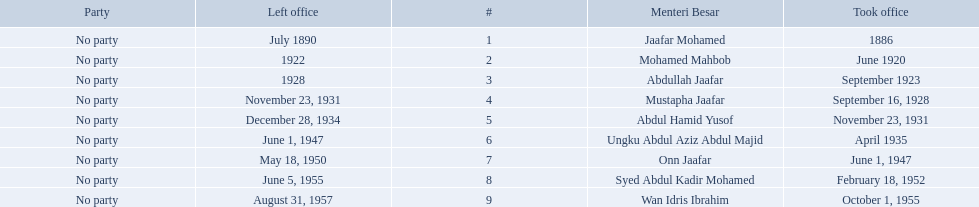When did jaafar mohamed take office? 1886. When did mohamed mahbob take office? June 1920. Who was in office no more than 4 years? Mohamed Mahbob. 